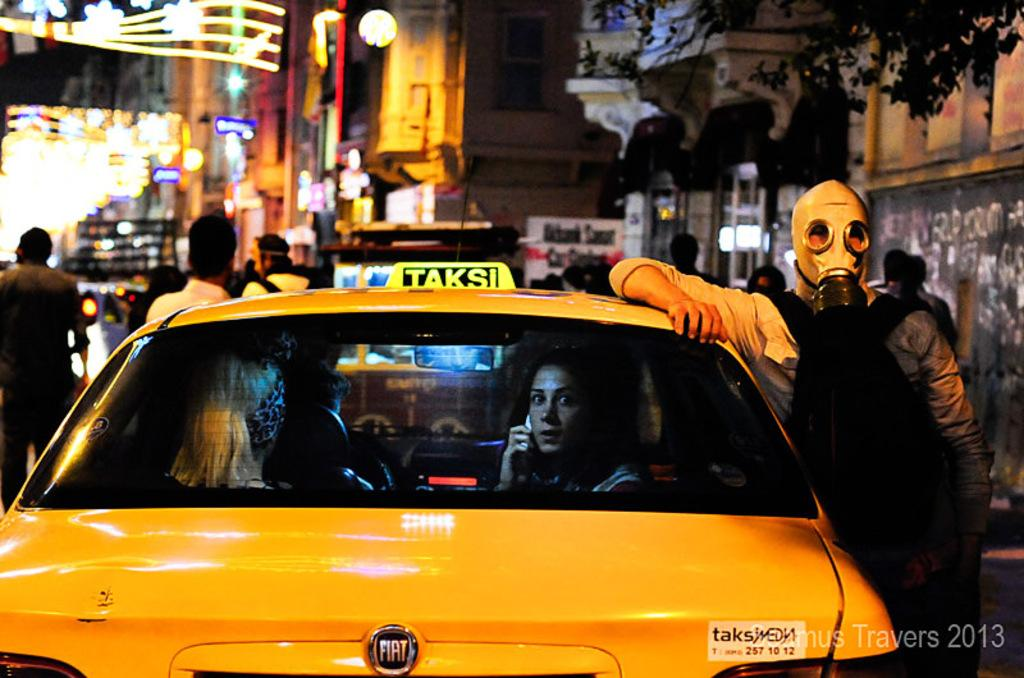<image>
Write a terse but informative summary of the picture. A man in a gas mask stands next to a taxi with the number 257 10 12 on it. 